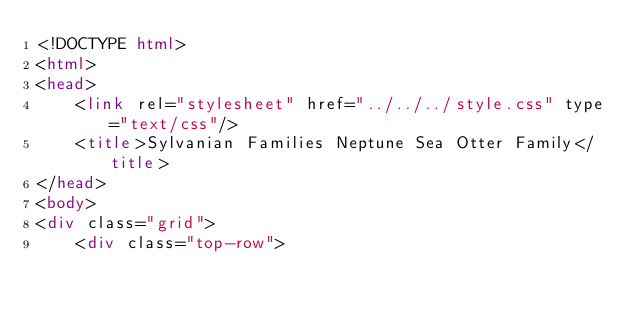<code> <loc_0><loc_0><loc_500><loc_500><_HTML_><!DOCTYPE html>
<html>
<head>
    <link rel="stylesheet" href="../../../style.css" type="text/css"/>
    <title>Sylvanian Families Neptune Sea Otter Family</title>
</head>
<body>
<div class="grid">
    <div class="top-row"></code> 